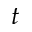<formula> <loc_0><loc_0><loc_500><loc_500>t</formula> 